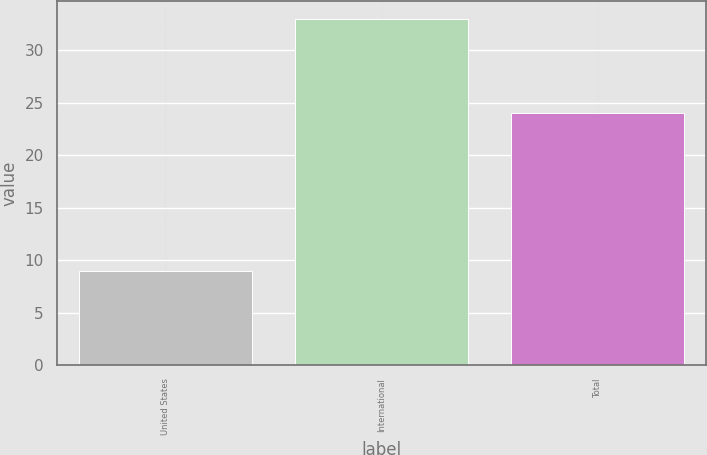<chart> <loc_0><loc_0><loc_500><loc_500><bar_chart><fcel>United States<fcel>International<fcel>Total<nl><fcel>9<fcel>33<fcel>24<nl></chart> 